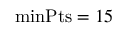<formula> <loc_0><loc_0><loc_500><loc_500>\min P t s = 1 5</formula> 